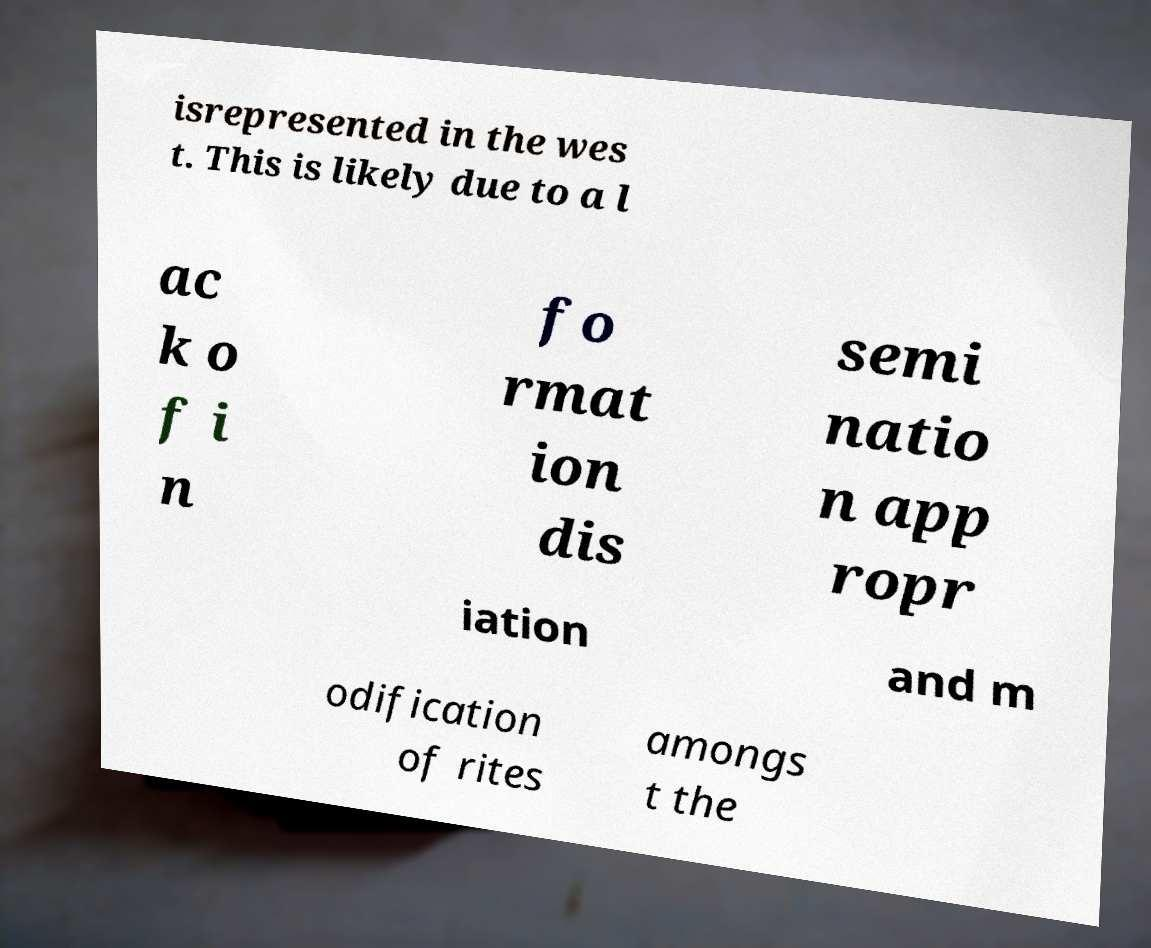Please read and relay the text visible in this image. What does it say? isrepresented in the wes t. This is likely due to a l ac k o f i n fo rmat ion dis semi natio n app ropr iation and m odification of rites amongs t the 